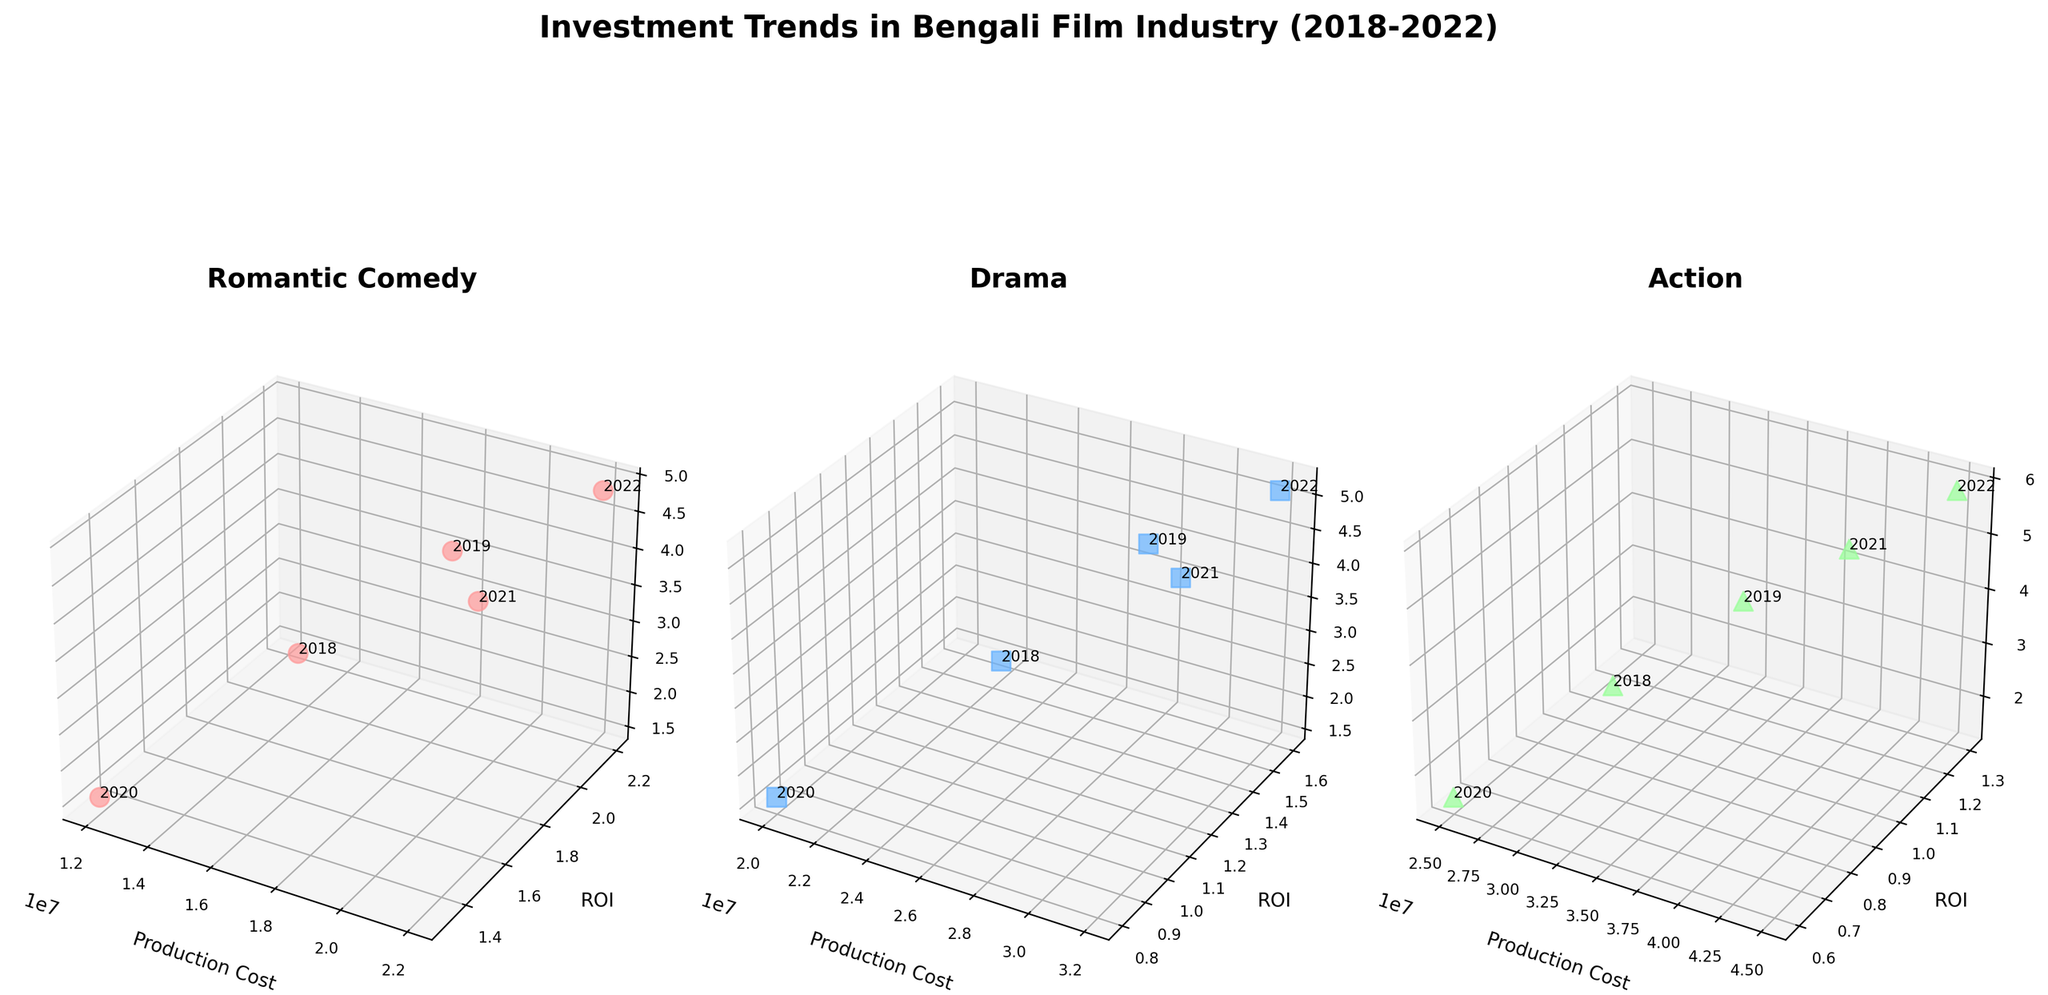What is the title of the figure? The title is displayed at the top of the figure.
Answer: Investment Trends in Bengali Film Industry (2018-2022) How many genres are depicted in the figure? There are three subplots, each representing a different genre of films in the Bengali film industry.
Answer: Three What is the axis label for the x-axis in each subplot? The label for the x-axis in each subplot is clearly indicated.
Answer: Production Cost In the Romantic Comedy genre, which year had the highest ROI? By examining the markers and annotations in the Romantic Comedy subplot, the highest ROI is identified.
Answer: 2022 How does the production cost of Action movies change from 2018 to 2022? By comparing the 3D coordinates of the markers for Action genre across the years, the changes in production costs are discernible.
Answer: Increases Which genre had the highest box office collections in 2021? By comparing the z-axis values for all genres in the year 2021, the highest box office collections can be determined.
Answer: Action What is the difference in production costs between Romantic Comedy and Drama in 2020? The production costs for both genres in 2020 are located and the difference is calculated.
Answer: 8,000,000 In which year did the Action genre have the lowest ROI? By checking the coordinates in the Action subplot, the year with the lowest ROI can be found.
Answer: 2020 Which funding source contributed to the highest production cost for a film in the Drama genre? By identifying the highest x-axis value in the Drama subplot and noting the corresponding funding source.
Answer: Windows Production 